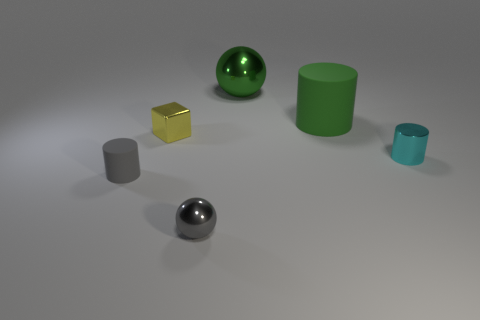Add 3 green shiny balls. How many objects exist? 9 Subtract all balls. How many objects are left? 4 Subtract all gray objects. Subtract all big spheres. How many objects are left? 3 Add 4 cyan cylinders. How many cyan cylinders are left? 5 Add 4 small green matte things. How many small green matte things exist? 4 Subtract 0 yellow cylinders. How many objects are left? 6 